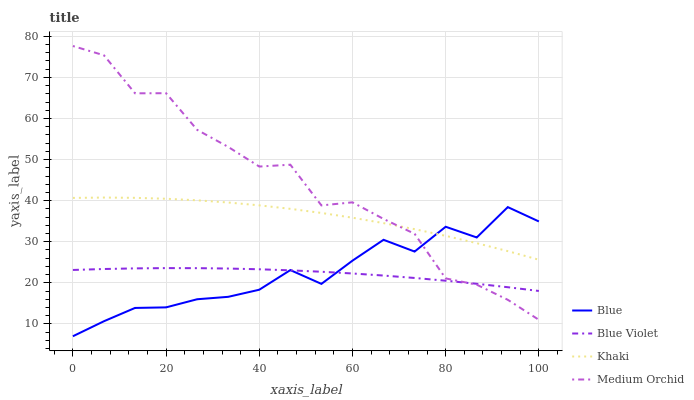Does Blue Violet have the minimum area under the curve?
Answer yes or no. Yes. Does Medium Orchid have the maximum area under the curve?
Answer yes or no. Yes. Does Khaki have the minimum area under the curve?
Answer yes or no. No. Does Khaki have the maximum area under the curve?
Answer yes or no. No. Is Blue Violet the smoothest?
Answer yes or no. Yes. Is Medium Orchid the roughest?
Answer yes or no. Yes. Is Khaki the smoothest?
Answer yes or no. No. Is Khaki the roughest?
Answer yes or no. No. Does Blue have the lowest value?
Answer yes or no. Yes. Does Medium Orchid have the lowest value?
Answer yes or no. No. Does Medium Orchid have the highest value?
Answer yes or no. Yes. Does Khaki have the highest value?
Answer yes or no. No. Is Blue Violet less than Khaki?
Answer yes or no. Yes. Is Khaki greater than Blue Violet?
Answer yes or no. Yes. Does Medium Orchid intersect Blue Violet?
Answer yes or no. Yes. Is Medium Orchid less than Blue Violet?
Answer yes or no. No. Is Medium Orchid greater than Blue Violet?
Answer yes or no. No. Does Blue Violet intersect Khaki?
Answer yes or no. No. 